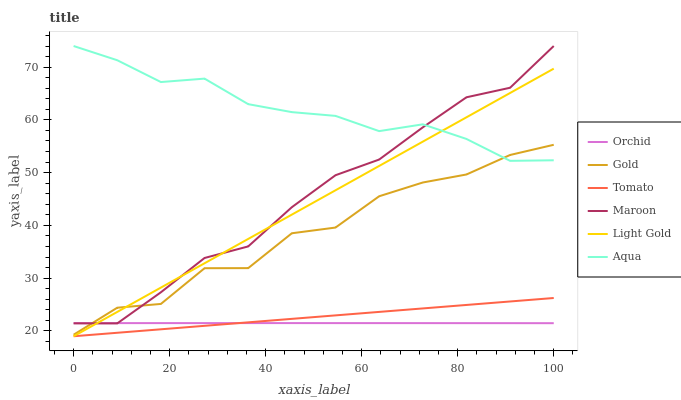Does Gold have the minimum area under the curve?
Answer yes or no. No. Does Gold have the maximum area under the curve?
Answer yes or no. No. Is Aqua the smoothest?
Answer yes or no. No. Is Aqua the roughest?
Answer yes or no. No. Does Gold have the lowest value?
Answer yes or no. No. Does Gold have the highest value?
Answer yes or no. No. Is Orchid less than Aqua?
Answer yes or no. Yes. Is Gold greater than Tomato?
Answer yes or no. Yes. Does Orchid intersect Aqua?
Answer yes or no. No. 